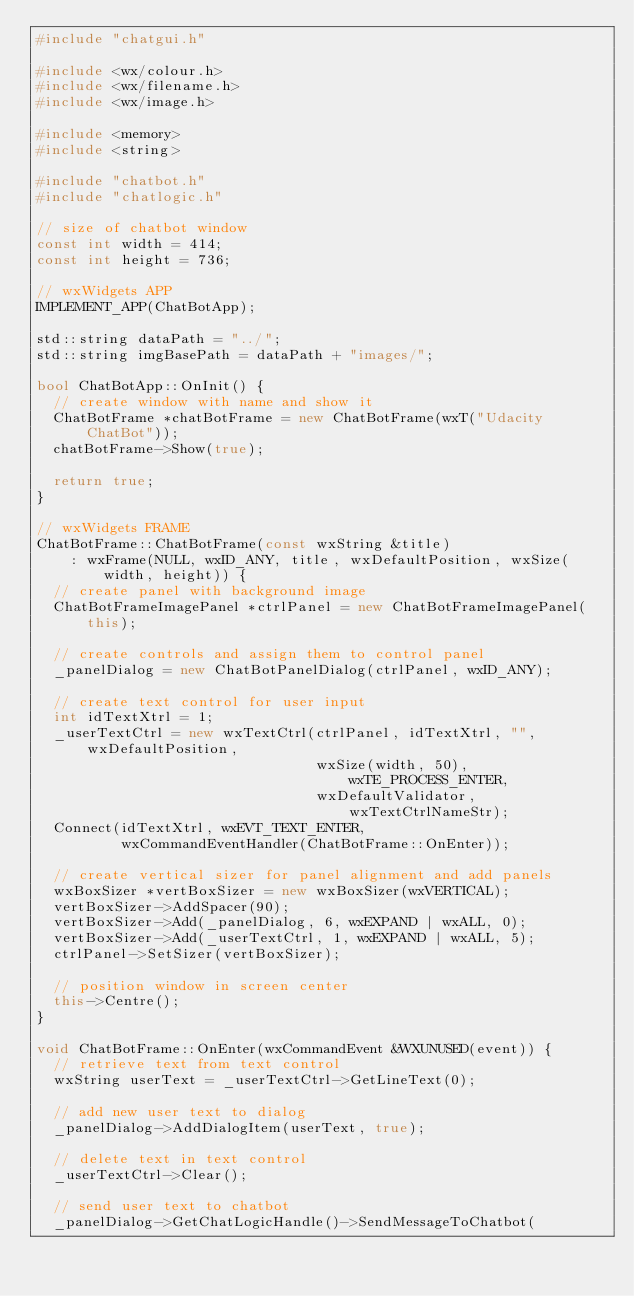<code> <loc_0><loc_0><loc_500><loc_500><_C++_>#include "chatgui.h"

#include <wx/colour.h>
#include <wx/filename.h>
#include <wx/image.h>

#include <memory>
#include <string>

#include "chatbot.h"
#include "chatlogic.h"

// size of chatbot window
const int width = 414;
const int height = 736;

// wxWidgets APP
IMPLEMENT_APP(ChatBotApp);

std::string dataPath = "../";
std::string imgBasePath = dataPath + "images/";

bool ChatBotApp::OnInit() {
  // create window with name and show it
  ChatBotFrame *chatBotFrame = new ChatBotFrame(wxT("Udacity ChatBot"));
  chatBotFrame->Show(true);

  return true;
}

// wxWidgets FRAME
ChatBotFrame::ChatBotFrame(const wxString &title)
    : wxFrame(NULL, wxID_ANY, title, wxDefaultPosition, wxSize(width, height)) {
  // create panel with background image
  ChatBotFrameImagePanel *ctrlPanel = new ChatBotFrameImagePanel(this);

  // create controls and assign them to control panel
  _panelDialog = new ChatBotPanelDialog(ctrlPanel, wxID_ANY);

  // create text control for user input
  int idTextXtrl = 1;
  _userTextCtrl = new wxTextCtrl(ctrlPanel, idTextXtrl, "", wxDefaultPosition,
                                 wxSize(width, 50), wxTE_PROCESS_ENTER,
                                 wxDefaultValidator, wxTextCtrlNameStr);
  Connect(idTextXtrl, wxEVT_TEXT_ENTER,
          wxCommandEventHandler(ChatBotFrame::OnEnter));

  // create vertical sizer for panel alignment and add panels
  wxBoxSizer *vertBoxSizer = new wxBoxSizer(wxVERTICAL);
  vertBoxSizer->AddSpacer(90);
  vertBoxSizer->Add(_panelDialog, 6, wxEXPAND | wxALL, 0);
  vertBoxSizer->Add(_userTextCtrl, 1, wxEXPAND | wxALL, 5);
  ctrlPanel->SetSizer(vertBoxSizer);

  // position window in screen center
  this->Centre();
}

void ChatBotFrame::OnEnter(wxCommandEvent &WXUNUSED(event)) {
  // retrieve text from text control
  wxString userText = _userTextCtrl->GetLineText(0);

  // add new user text to dialog
  _panelDialog->AddDialogItem(userText, true);

  // delete text in text control
  _userTextCtrl->Clear();

  // send user text to chatbot
  _panelDialog->GetChatLogicHandle()->SendMessageToChatbot(</code> 